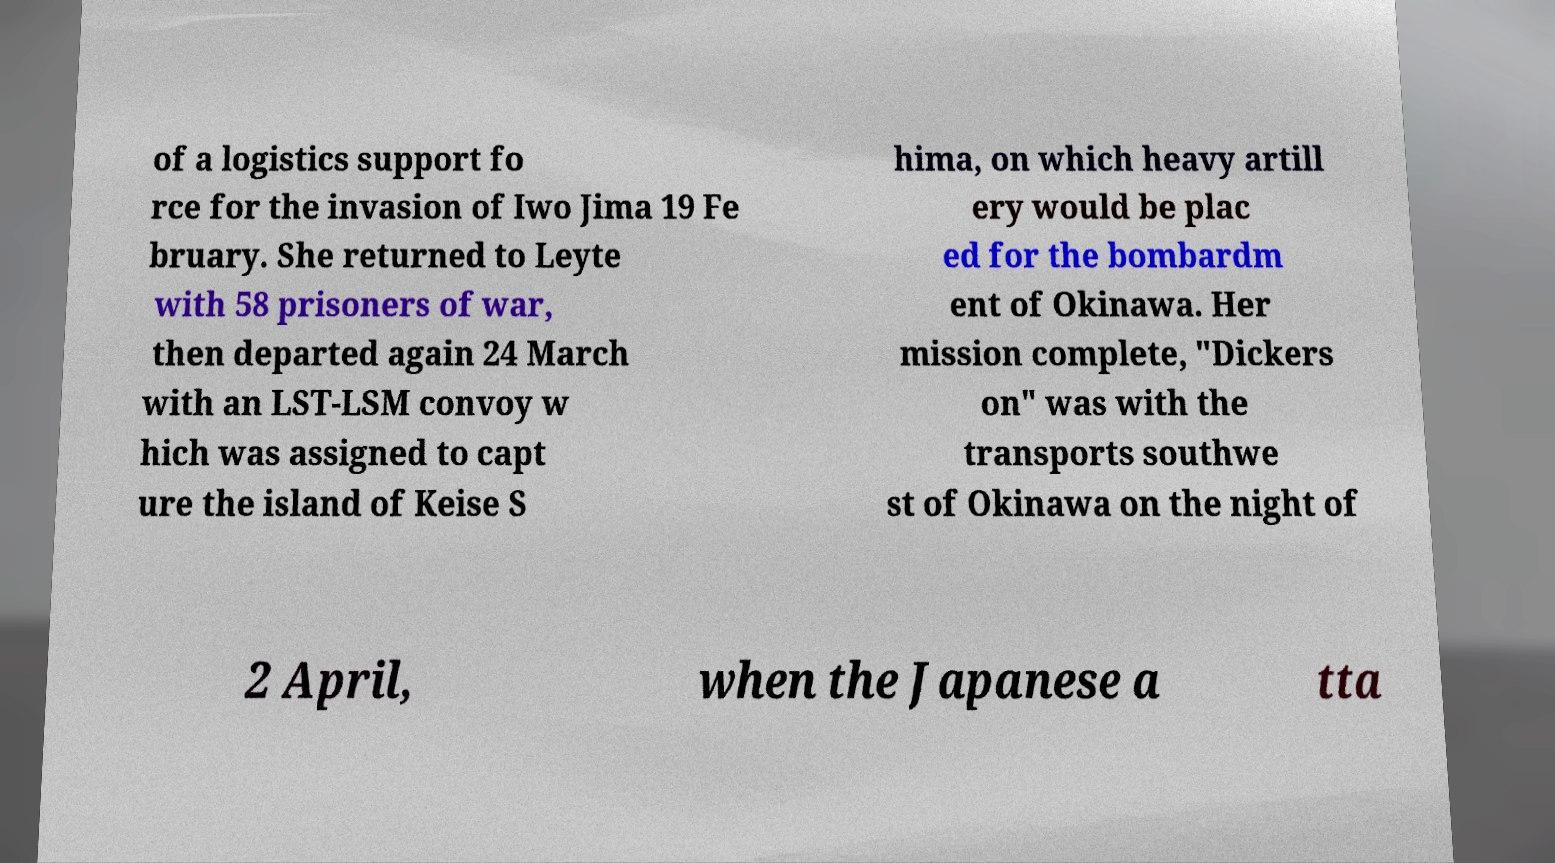I need the written content from this picture converted into text. Can you do that? of a logistics support fo rce for the invasion of Iwo Jima 19 Fe bruary. She returned to Leyte with 58 prisoners of war, then departed again 24 March with an LST-LSM convoy w hich was assigned to capt ure the island of Keise S hima, on which heavy artill ery would be plac ed for the bombardm ent of Okinawa. Her mission complete, "Dickers on" was with the transports southwe st of Okinawa on the night of 2 April, when the Japanese a tta 